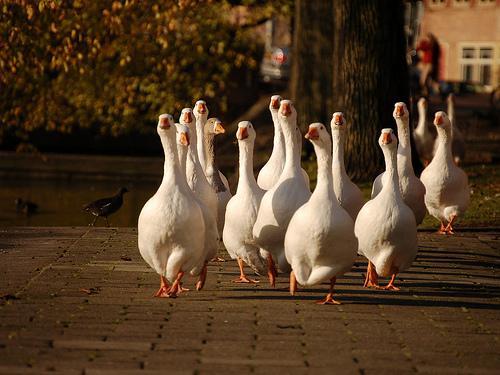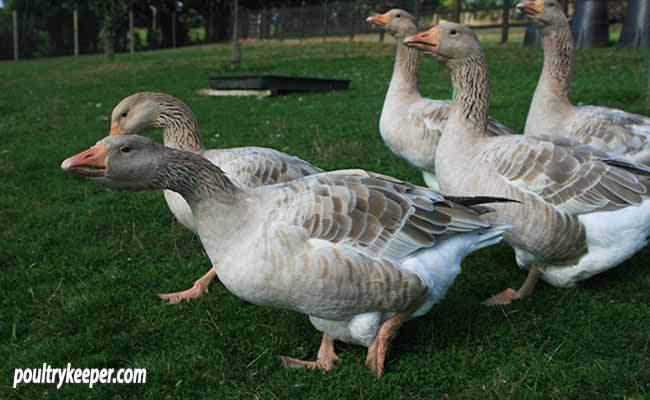The first image is the image on the left, the second image is the image on the right. Examine the images to the left and right. Is the description "There are multiple birds walking and grazing on patchy grass with dirt showing." accurate? Answer yes or no. No. 